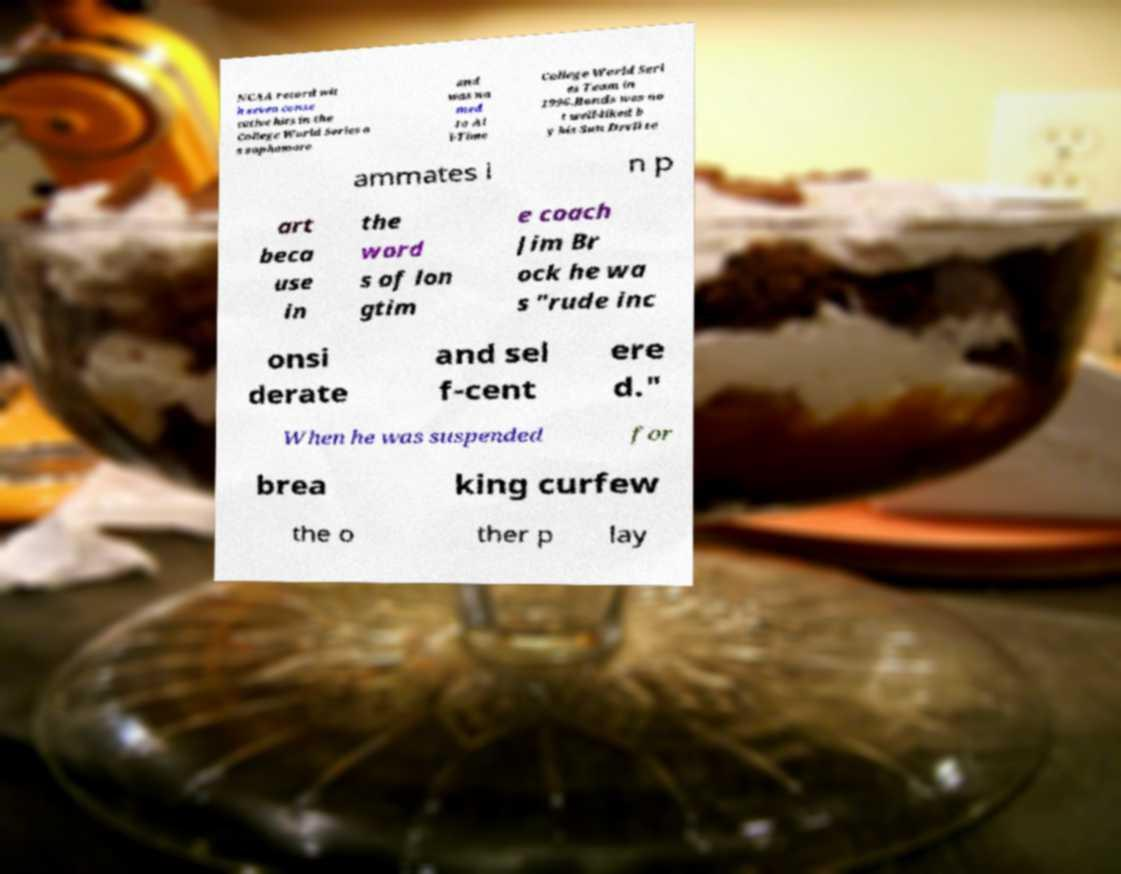Could you assist in decoding the text presented in this image and type it out clearly? NCAA record wit h seven conse cutive hits in the College World Series a s sophomore and was na med to Al l-Time College World Seri es Team in 1996.Bonds was no t well-liked b y his Sun Devil te ammates i n p art beca use in the word s of lon gtim e coach Jim Br ock he wa s "rude inc onsi derate and sel f-cent ere d." When he was suspended for brea king curfew the o ther p lay 